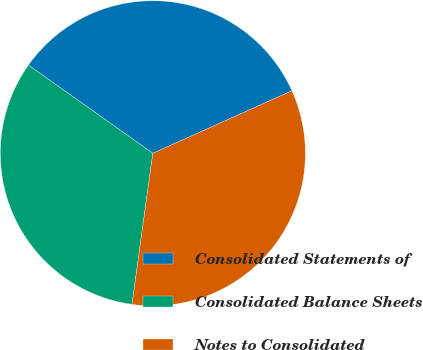<chart> <loc_0><loc_0><loc_500><loc_500><pie_chart><fcel>Consolidated Statements of<fcel>Consolidated Balance Sheets<fcel>Notes to Consolidated<nl><fcel>33.47%<fcel>32.63%<fcel>33.9%<nl></chart> 